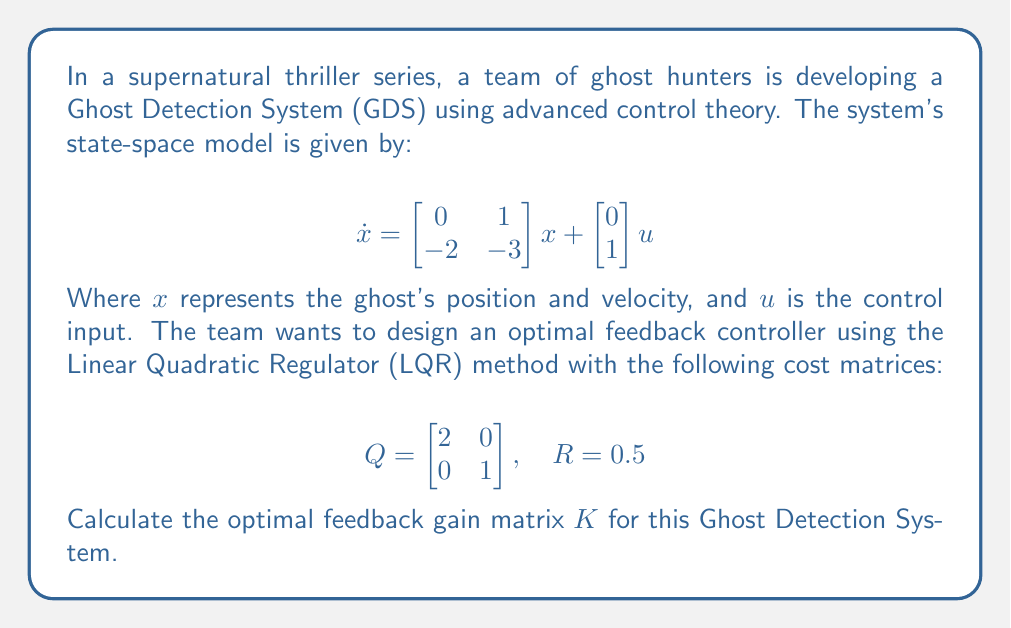Provide a solution to this math problem. To solve this problem, we'll use the Linear Quadratic Regulator (LQR) method. The steps are as follows:

1. Identify the system matrices:
   $$A = \begin{bmatrix} 0 & 1 \\ -2 & -3 \end{bmatrix}, \quad B = \begin{bmatrix} 0 \\ 1 \end{bmatrix}$$

2. Solve the Algebraic Riccati Equation (ARE):
   $$A^TP + PA - PBR^{-1}B^TP + Q = 0$$

   Let $P = \begin{bmatrix} p_{11} & p_{12} \\ p_{12} & p_{22} \end{bmatrix}$

3. Expand the ARE:
   $$\begin{bmatrix} 0 & -2 \\ 1 & -3 \end{bmatrix}\begin{bmatrix} p_{11} & p_{12} \\ p_{12} & p_{22} \end{bmatrix} + \begin{bmatrix} p_{11} & p_{12} \\ p_{12} & p_{22} \end{bmatrix}\begin{bmatrix} 0 & 1 \\ -2 & -3 \end{bmatrix} - \begin{bmatrix} p_{11} & p_{12} \\ p_{12} & p_{22} \end{bmatrix}\begin{bmatrix} 0 \\ 1 \end{bmatrix}(0.5)^{-1}\begin{bmatrix} 0 & 1 \end{bmatrix}\begin{bmatrix} p_{11} & p_{12} \\ p_{12} & p_{22} \end{bmatrix} + \begin{bmatrix} 2 & 0 \\ 0 & 1 \end{bmatrix} = 0$$

4. Solve the resulting system of equations:
   $$-2p_{12} = p_{11}$$
   $$p_{11} - 2p_{22} - 2p_{12}^2 = 0$$
   $$-2p_{11} - 3p_{12} + p_{12} - 2p_{12}p_{22} = 0$$
   $$2p_{12} - 3p_{22} - 2p_{22}^2 + 1 = 0$$

5. The solution to this system is:
   $$p_{11} = 2, \quad p_{12} = -1, \quad p_{22} = 1$$

6. Calculate the optimal feedback gain $K$:
   $$K = R^{-1}B^TP = (0.5)^{-1}\begin{bmatrix} 0 & 1 \end{bmatrix}\begin{bmatrix} 2 & -1 \\ -1 & 1 \end{bmatrix} = \begin{bmatrix} -2 & 2 \end{bmatrix}$$

Therefore, the optimal feedback gain matrix $K$ for the Ghost Detection System is $\begin{bmatrix} -2 & 2 \end{bmatrix}$.
Answer: $K = \begin{bmatrix} -2 & 2 \end{bmatrix}$ 